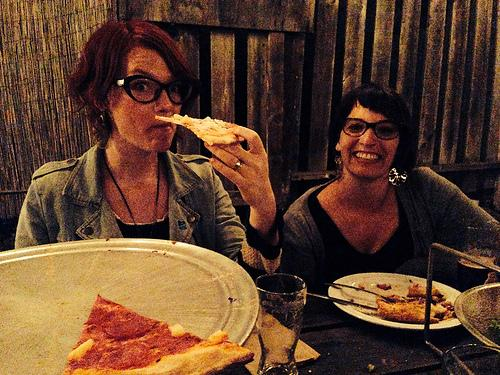Identify the notable objects present in the image and their specific locations. There are two women in the image: one wearing dark glasses and a denim jacket, and the other with brown hair and a grey sweater. There is a piece of pizza on a metal pan and a slice of pizza in a hand. An empty glass, plate and partially eaten food are on the table. A silver ring, a necklace, large earring, and spectacles are worn by the women. Considering the image elements and their relationships, develop a complex reasoning question and answer it. The two women could be friends or coworkers, and they may have gathered to enjoy a casual meal together or to celebrate a particular occasion like a birthday or a promotion. Assess the image quality based on the clarity of objects and details. The image quality is good, as the objects are clearly visible, and the details of the wall, women's clothing, food, and jewelry are noticeable. What are the two women in the image doing? The two women are seated at the table, one woman is eating a slice of pizza and the other is smiling at the camera. Mention the jewelry items seen on the women and their respective positions. The woman in the denim jacket is wearing large earrings, a necklace around her neck, a silver ring on her finger, and dark glasses. The woman with brown hair is also wearing a ring on her finger. What is the sentiment of the two women in the image? The women seem to be enjoying their time together, as one is eating a slice of pizza and the other is smiling at the camera. Count the number of eating utensils present on the table. There are two utensils on the white plate. Describe the appearance of the wall in the image. The wall is made of thick wooden boards and has a rustic appearance. Analyze the interaction between the objects in the image and describe the scene. In the image, the two women are seated at a table sharing a meal that includes pizza and a variety of beverages. They are wearing jewelry and engaged in a pleasant conversation, evident by one woman smiling at the camera and the other eating a slice of pizza. What type of food is on the plate and in what condition is it? The food on the plate is partially eaten and appears to be the last piece of pizza. What is happening in this photo? Two women are eating pizza together at a table. Describe the wall behind the women. The wall is made of thick wood boards arranged horizontally. Describe the pizza slice the woman is holding. It is a piece of pepperoni pizza with a partially eaten crust. Identify the type of event taking place in the photo. A casual meal between friends Write a short story about this image using visual details. Jane and Alice wandered into a cozy pizzeria nestled among the bustling city streets. The atmosphere was inviting, and the laughter between them flowed as easily as the beer they shared. As they savored the last slice of their pepperoni pizza, a still moment captured their friendship, framed by the warm glow of the wooden wall. Tales sparkled in the air, with silver rings and bold earrings adorning the carefree evening. Is the pizza slice on a tray or directly on the table? Choose among: (a) Tray, (b) Table, (c) Neither. (a) Tray Which drink is empty on the table? Beer glass What are the women doing together? Sitting and sharing pizza What is the main subject in this photo? Two women eating pizza at a table Create a poem describing the image using visual elements. Amidst the wooden wall's embrace, Which color is the woman's denim jacket? Green Explain the structural arrangement of the wooden wall. The wall is composed of wooden boards arranged horizontally. Caption the image with a humorous turn of phrase. Last slice showdown: May the cheesiest win! Describe the scene in a poetic manner. Two lovely ladies feast on pizza's final slice, as an empty beer glass catches the light, surrounded by the memory of a delightful night. Analyze how the pizza slice is positioned. The pizza slice is positioned on a metal tray. What activity are the women participating in? Eating pizza Identify any text visible in the image. No text is visible in the image. List any numbers or letters that can be seen in the image. There are no visible numbers or letters in the image. 